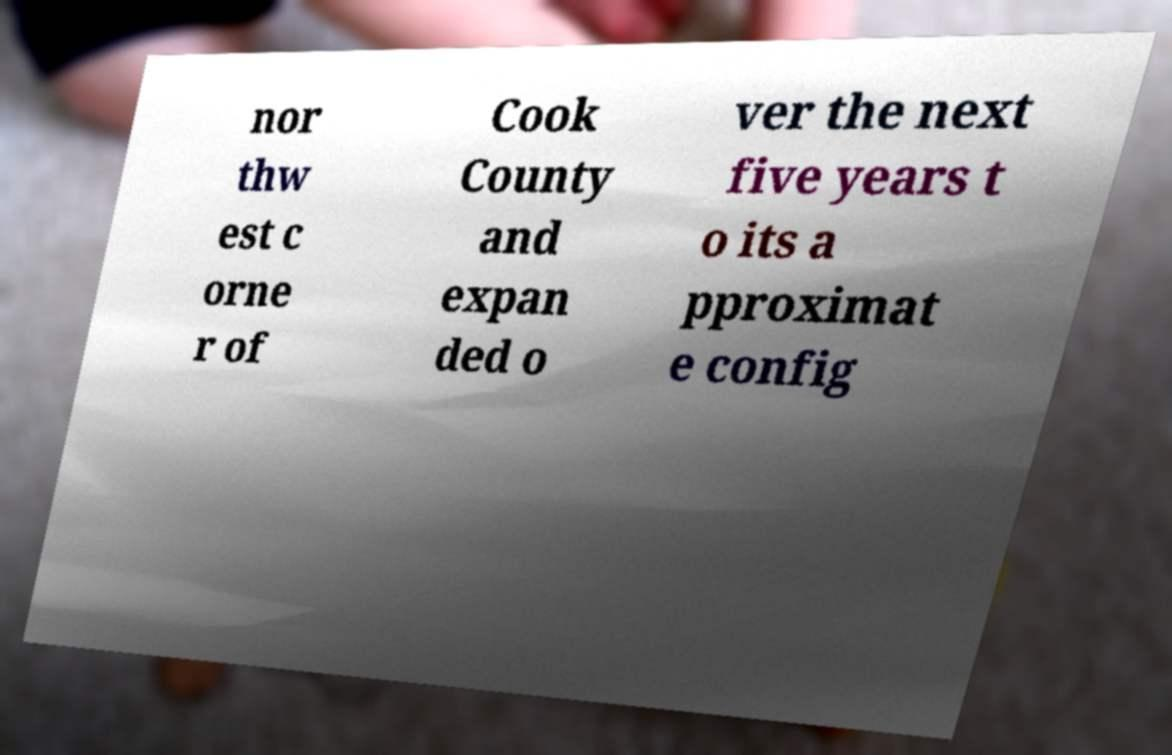There's text embedded in this image that I need extracted. Can you transcribe it verbatim? nor thw est c orne r of Cook County and expan ded o ver the next five years t o its a pproximat e config 